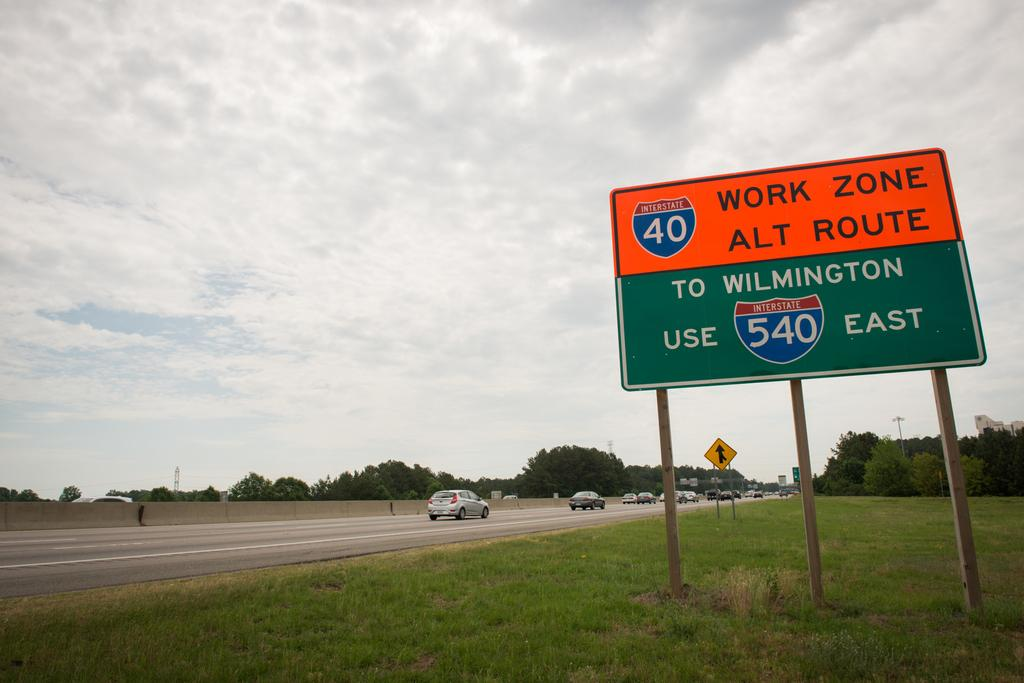<image>
Create a compact narrative representing the image presented. A road sign along Interstate 40 warning of construction and recommending an alternate route of Wilmington 540 East instead. 